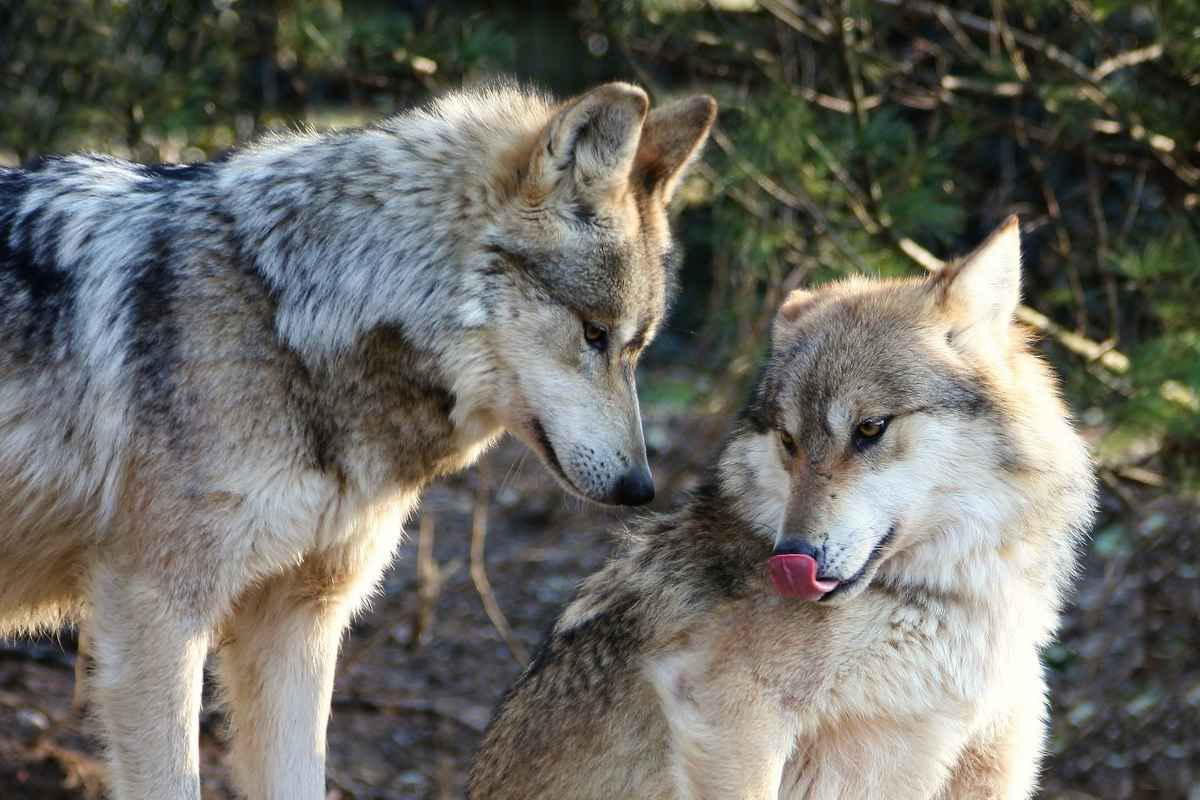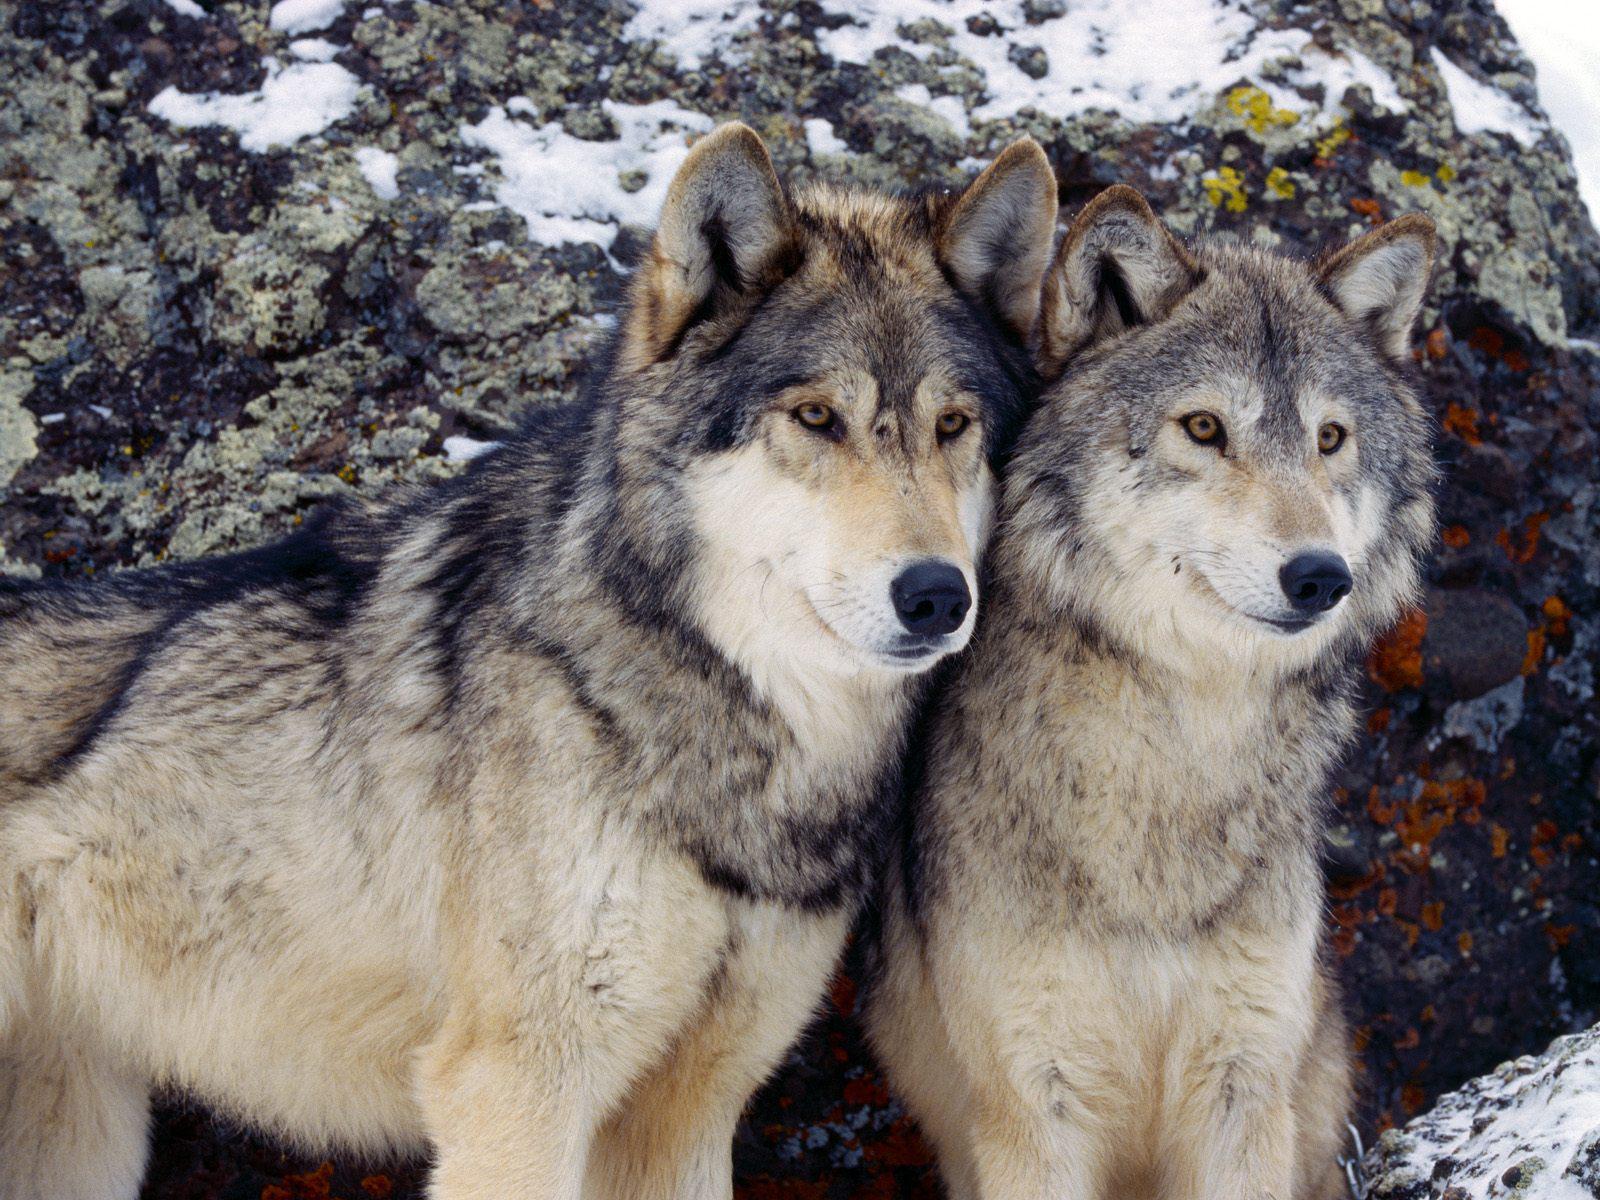The first image is the image on the left, the second image is the image on the right. Considering the images on both sides, is "The image on the right contains exactly one black wolf" valid? Answer yes or no. No. The first image is the image on the left, the second image is the image on the right. Examine the images to the left and right. Is the description "The image on the right contains one wolf with a black colored head." accurate? Answer yes or no. No. 